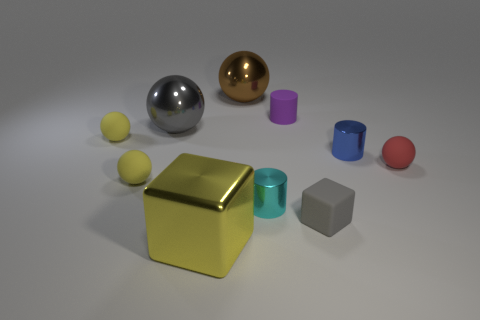Can you describe the lighting in this scene? The image features soft, diffuse lighting, which casts gentle shadows and gives the scene a calm, studio-like atmosphere. The light source appears to be situated overhead, possibly out of frame, providing an even illumination across the various objects. 